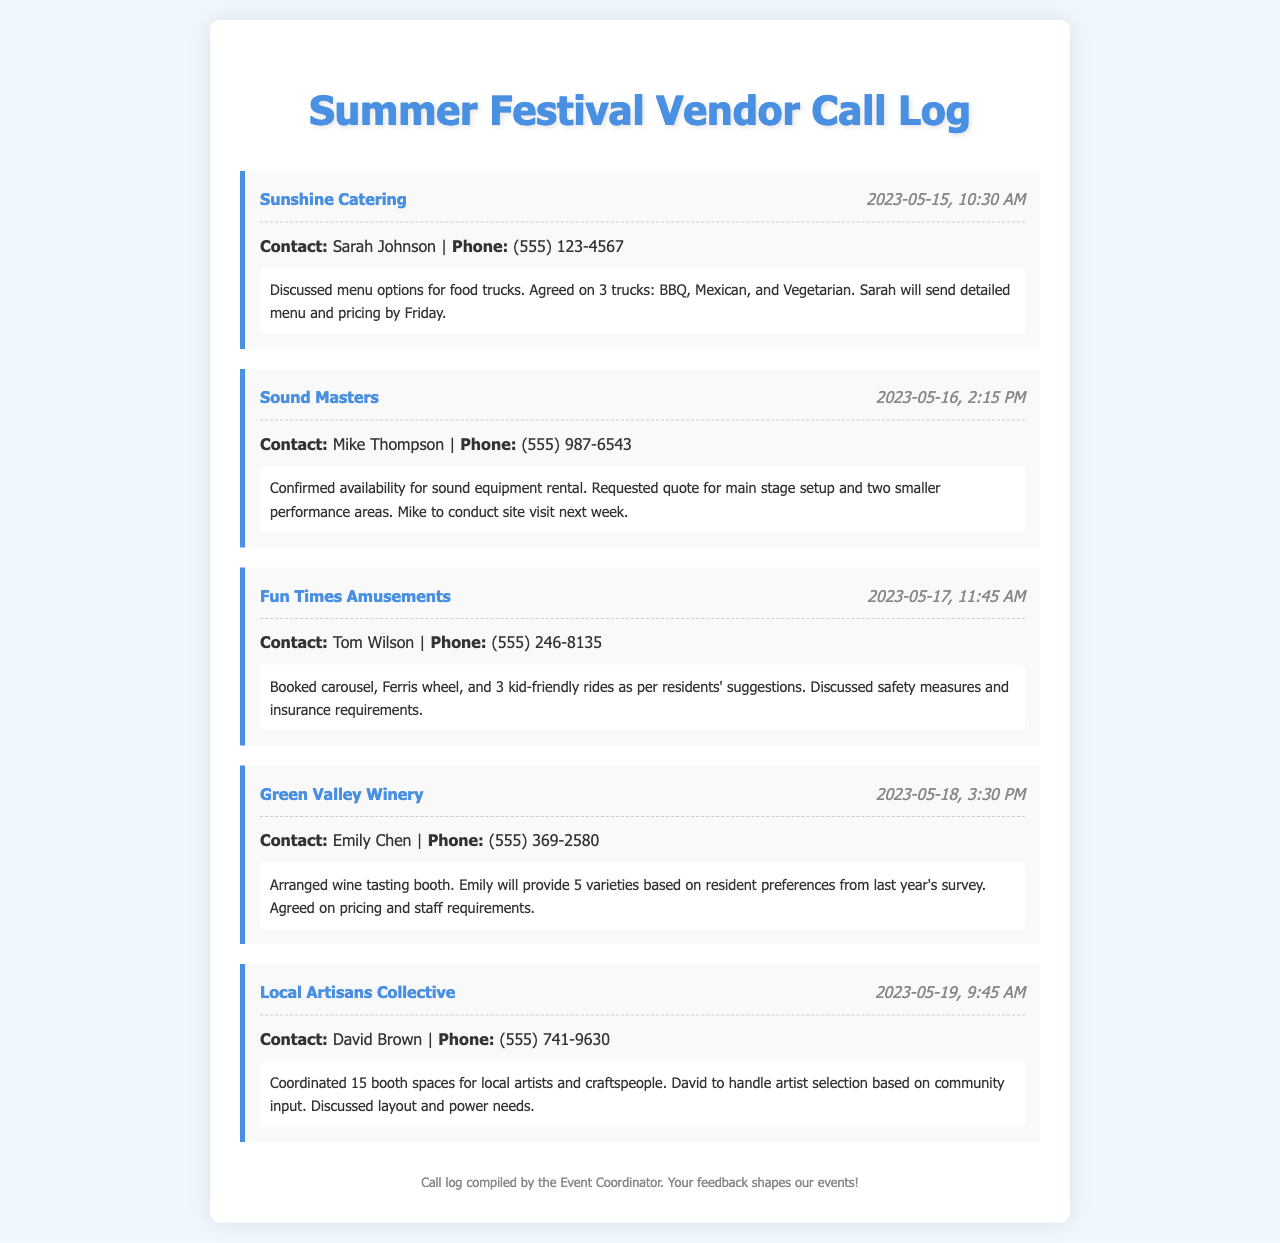What is the name of the first vendor contacted? The first vendor listed in the call log is Sunshine Catering.
Answer: Sunshine Catering Who is the contact person for Sound Masters? The call details include Mike Thompson as the contact for Sound Masters.
Answer: Mike Thompson What date was the call with Fun Times Amusements made? The call log indicates that the call with Fun Times Amusements took place on May 17, 2023.
Answer: 2023-05-17 How many rides were booked with Fun Times Amusements? The document mentions three rides booked: carousel, Ferris wheel, and 3 kid-friendly rides.
Answer: 5 What type of booth was arranged with Green Valley Winery? The document specifies that a wine tasting booth was arranged.
Answer: Wine tasting booth Who is responsible for artist selection in the Local Artisans Collective? David Brown is mentioned as the person handling artist selection based on community input.
Answer: David Brown What was discussed regarding the wine varieties? The agreement was for Emily to provide 5 varieties based on resident preferences from last year's survey.
Answer: 5 varieties What will Mike Thompson do next week? The notes indicate that Mike will conduct a site visit next week.
Answer: Conduct site visit 